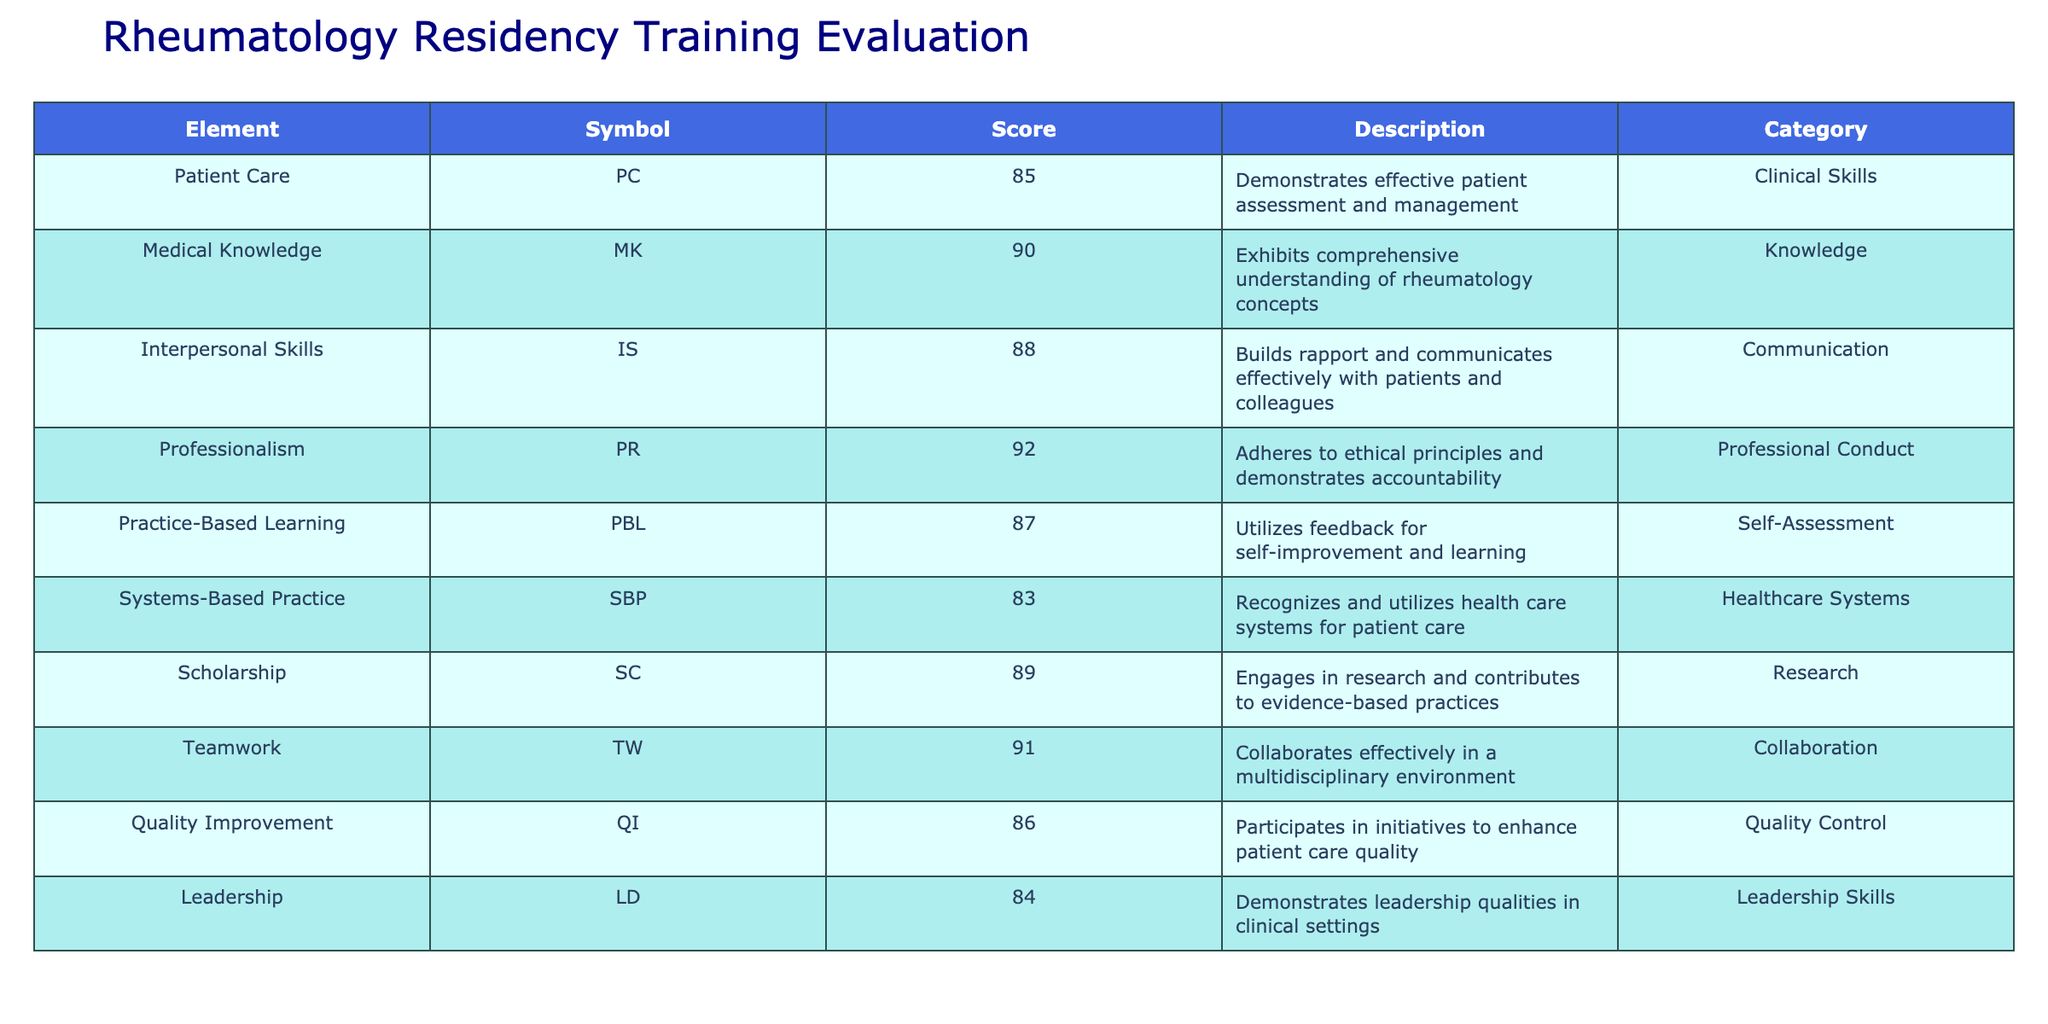What is the highest residency training evaluation score? The scores listed in the table are 85, 90, 88, 92, 87, 83, 89, 91, 86, and 84. Among these, 92 is the highest score, corresponding to the element Professionalism.
Answer: 92 What is the score for Teamwork? According to the table, the score for Teamwork is directly listed as 91.
Answer: 91 Which category has the lowest score? The scores for each category are as follows: Clinical Skills (85), Knowledge (90), Communication (88), Professional Conduct (92), Self-Assessment (87), Healthcare Systems (83), Research (89), Collaboration (91), Quality Control (86), and Leadership Skills (84). The lowest score is 83, belonging to Systems-Based Practice.
Answer: 83 What is the average score of the categories representing clinical skills and communication? The scores for Clinical Skills (85) and Communication (88) are added together: 85 + 88 = 173. To find the average, we divide by 2 (the number of categories): 173 / 2 = 86.5.
Answer: 86.5 Is the score for Medical Knowledge higher than that for Patient Care? The score for Medical Knowledge is 90 and for Patient Care is 85. Since 90 is greater than 85, the statement is true.
Answer: Yes What is the total of the scores for all categories? The scores are: 85, 90, 88, 92, 87, 83, 89, 91, 86, and 84. Summing these gives: 85 + 90 + 88 + 92 + 87 + 83 + 89 + 91 + 86 + 84 =  912.
Answer: 912 Which elements' scores are above 90? The scores above 90 from the table are for Professionalism (92), Teamwork (91), and Medical Knowledge (90). Therefore, the elements are Professionalism and Teamwork.
Answer: Professionalism, Teamwork How much higher is the score of Quality Improvement compared to Systems-Based Practice? The score for Quality Improvement is 86 and for Systems-Based Practice is 83. The difference is calculated as: 86 - 83 = 3.
Answer: 3 Which category should be focused on for improvement based on the scores? The lowest score is for Systems-Based Practice with a score of 83. Therefore, this category should be prioritized for improvement.
Answer: Systems-Based Practice 